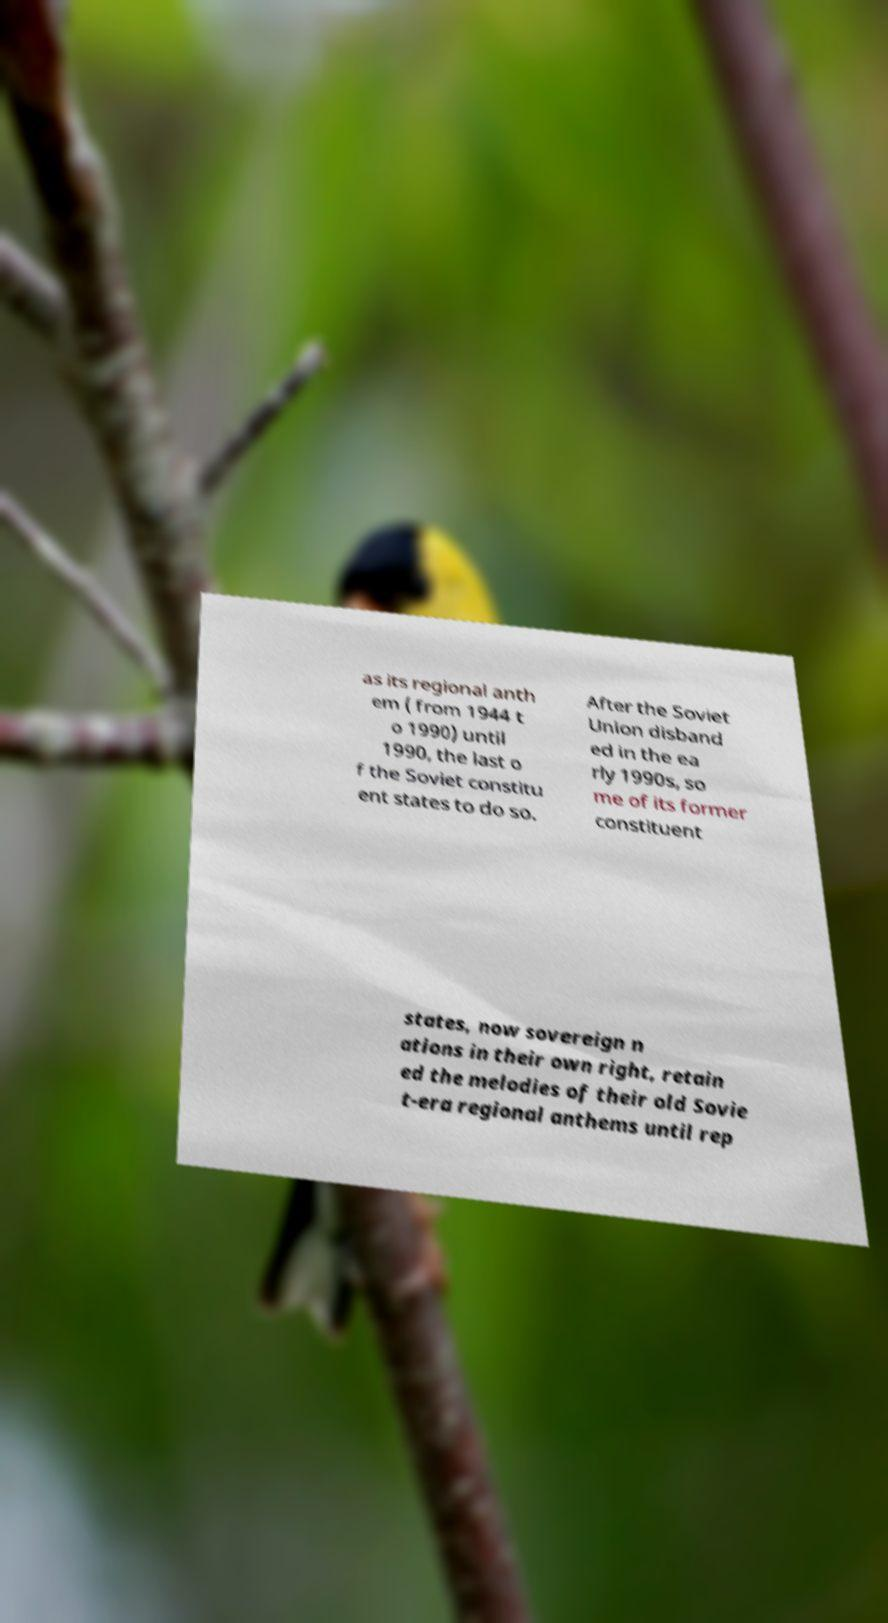Please read and relay the text visible in this image. What does it say? as its regional anth em ( from 1944 t o 1990) until 1990, the last o f the Soviet constitu ent states to do so. After the Soviet Union disband ed in the ea rly 1990s, so me of its former constituent states, now sovereign n ations in their own right, retain ed the melodies of their old Sovie t-era regional anthems until rep 